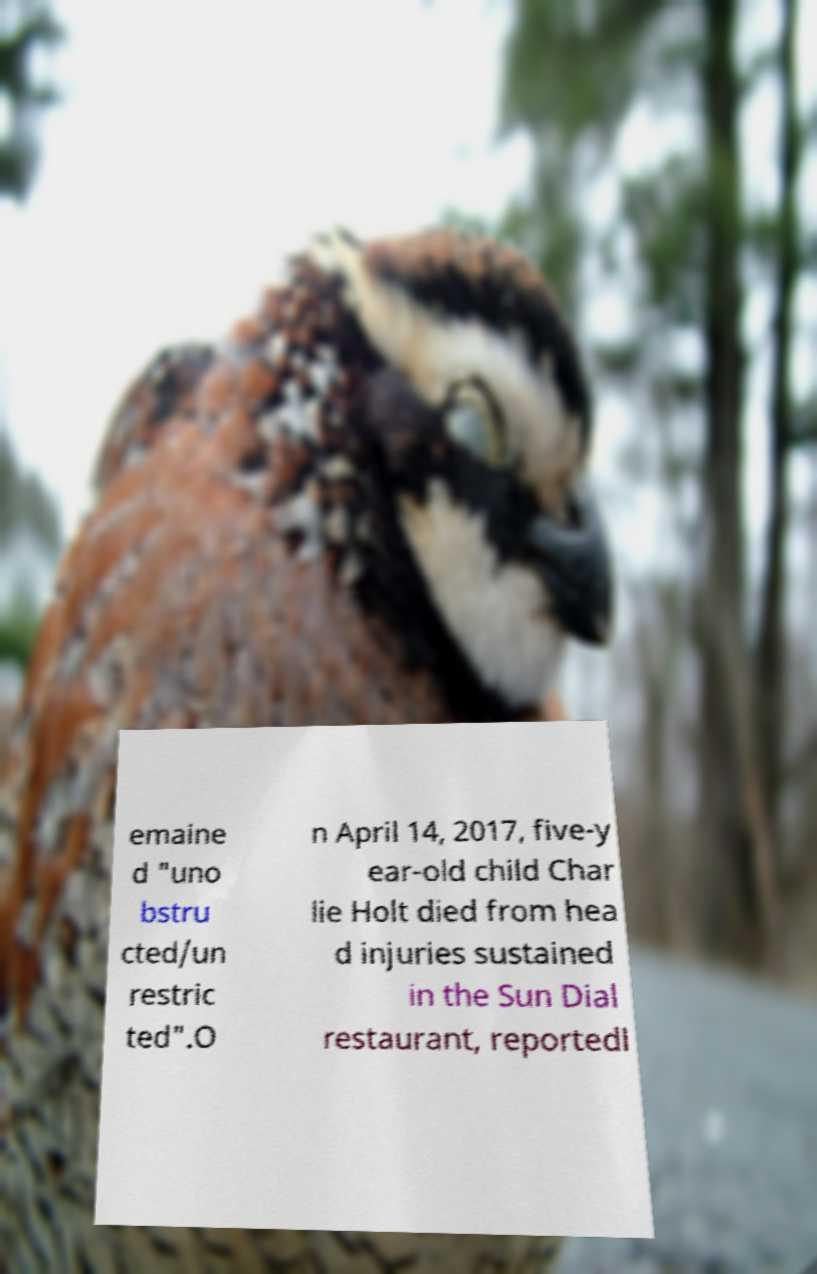Please identify and transcribe the text found in this image. emaine d "uno bstru cted/un restric ted".O n April 14, 2017, five-y ear-old child Char lie Holt died from hea d injuries sustained in the Sun Dial restaurant, reportedl 